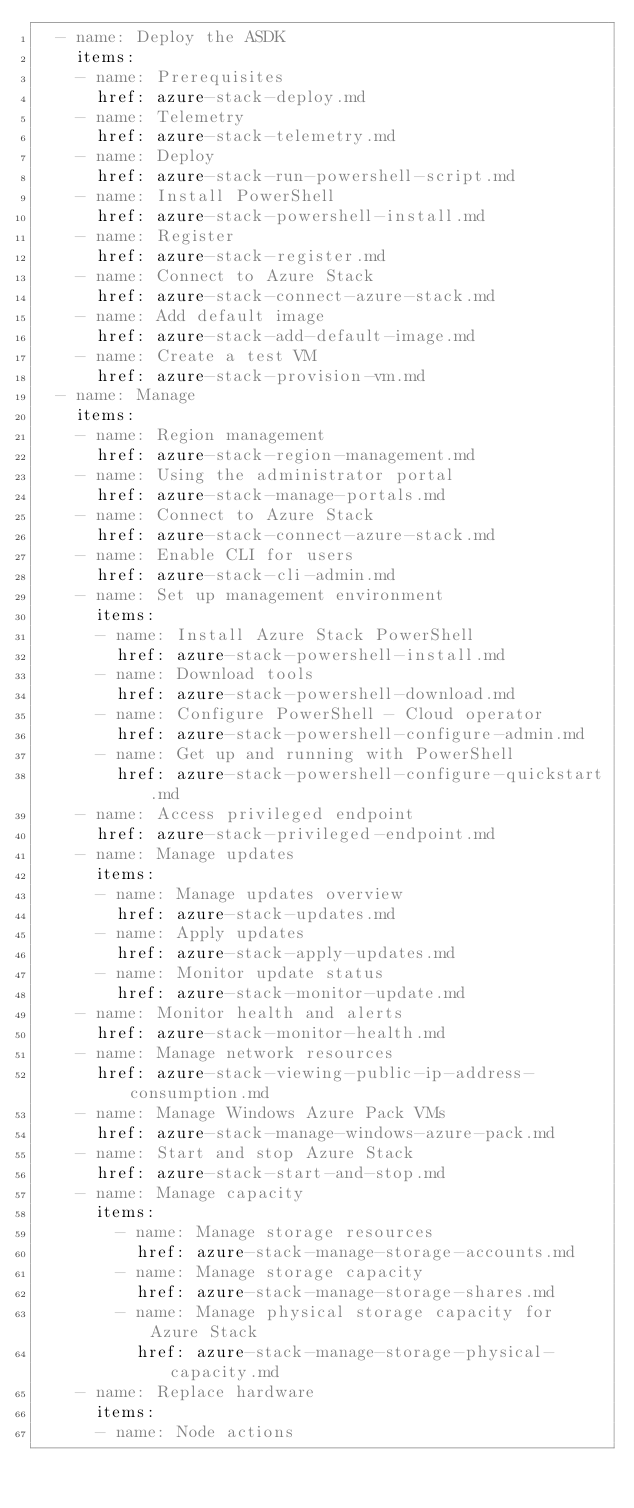<code> <loc_0><loc_0><loc_500><loc_500><_YAML_>  - name: Deploy the ASDK
    items:
    - name: Prerequisites
      href: azure-stack-deploy.md
    - name: Telemetry
      href: azure-stack-telemetry.md
    - name: Deploy
      href: azure-stack-run-powershell-script.md
    - name: Install PowerShell
      href: azure-stack-powershell-install.md
    - name: Register
      href: azure-stack-register.md
    - name: Connect to Azure Stack
      href: azure-stack-connect-azure-stack.md
    - name: Add default image
      href: azure-stack-add-default-image.md
    - name: Create a test VM
      href: azure-stack-provision-vm.md
  - name: Manage
    items:
    - name: Region management
      href: azure-stack-region-management.md
    - name: Using the administrator portal
      href: azure-stack-manage-portals.md
    - name: Connect to Azure Stack
      href: azure-stack-connect-azure-stack.md
    - name: Enable CLI for users
      href: azure-stack-cli-admin.md
    - name: Set up management environment
      items:
      - name: Install Azure Stack PowerShell
        href: azure-stack-powershell-install.md
      - name: Download tools
        href: azure-stack-powershell-download.md
      - name: Configure PowerShell - Cloud operator
        href: azure-stack-powershell-configure-admin.md
      - name: Get up and running with PowerShell
        href: azure-stack-powershell-configure-quickstart.md
    - name: Access privileged endpoint
      href: azure-stack-privileged-endpoint.md
    - name: Manage updates
      items:
      - name: Manage updates overview
        href: azure-stack-updates.md
      - name: Apply updates
        href: azure-stack-apply-updates.md
      - name: Monitor update status
        href: azure-stack-monitor-update.md
    - name: Monitor health and alerts
      href: azure-stack-monitor-health.md
    - name: Manage network resources
      href: azure-stack-viewing-public-ip-address-consumption.md
    - name: Manage Windows Azure Pack VMs
      href: azure-stack-manage-windows-azure-pack.md
    - name: Start and stop Azure Stack
      href: azure-stack-start-and-stop.md
    - name: Manage capacity
      items:
        - name: Manage storage resources
          href: azure-stack-manage-storage-accounts.md
        - name: Manage storage capacity
          href: azure-stack-manage-storage-shares.md
        - name: Manage physical storage capacity for Azure Stack
          href: azure-stack-manage-storage-physical-capacity.md
    - name: Replace hardware
      items:
      - name: Node actions</code> 